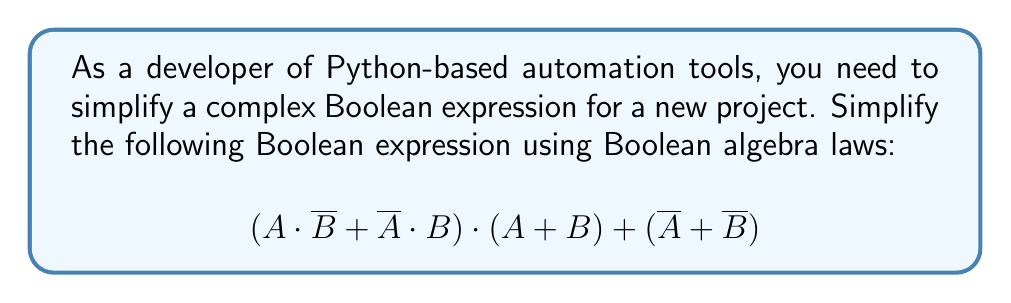Show me your answer to this math problem. Let's simplify this expression step by step:

1) First, let's focus on the term $(A \cdot \overline{B} + \overline{A} \cdot B)$. This is the XOR operation, which we can represent as $A \oplus B$.

2) Now our expression looks like:
   $$(A \oplus B) \cdot (A + B) + (\overline{A} + \overline{B})$$

3) Let's distribute $(A \oplus B)$ over $(A + B)$:
   $$(A \oplus B) \cdot A + (A \oplus B) \cdot B + (\overline{A} + \overline{B})$$

4) Simplify $(A \oplus B) \cdot A$:
   - When $A = 1$, $A \oplus B = \overline{B}$
   - So, $(A \oplus B) \cdot A = \overline{B} \cdot A$

5) Similarly, simplify $(A \oplus B) \cdot B$:
   - When $B = 1$, $A \oplus B = \overline{A}$
   - So, $(A \oplus B) \cdot B = \overline{A} \cdot B$

6) Our expression is now:
   $$\overline{B} \cdot A + \overline{A} \cdot B + (\overline{A} + \overline{B})$$

7) The first two terms $\overline{B} \cdot A + \overline{A} \cdot B$ are again the XOR operation $A \oplus B$

8) So we have:
   $$(A \oplus B) + (\overline{A} + \overline{B})$$

9) Using De Morgan's law, $(\overline{A} + \overline{B}) = \overline{(A \cdot B)}$

10) Our final simplified expression is:
    $$(A \oplus B) + \overline{(A \cdot B)}$$

This cannot be simplified further using Boolean algebra laws.
Answer: $(A \oplus B) + \overline{(A \cdot B)}$ 